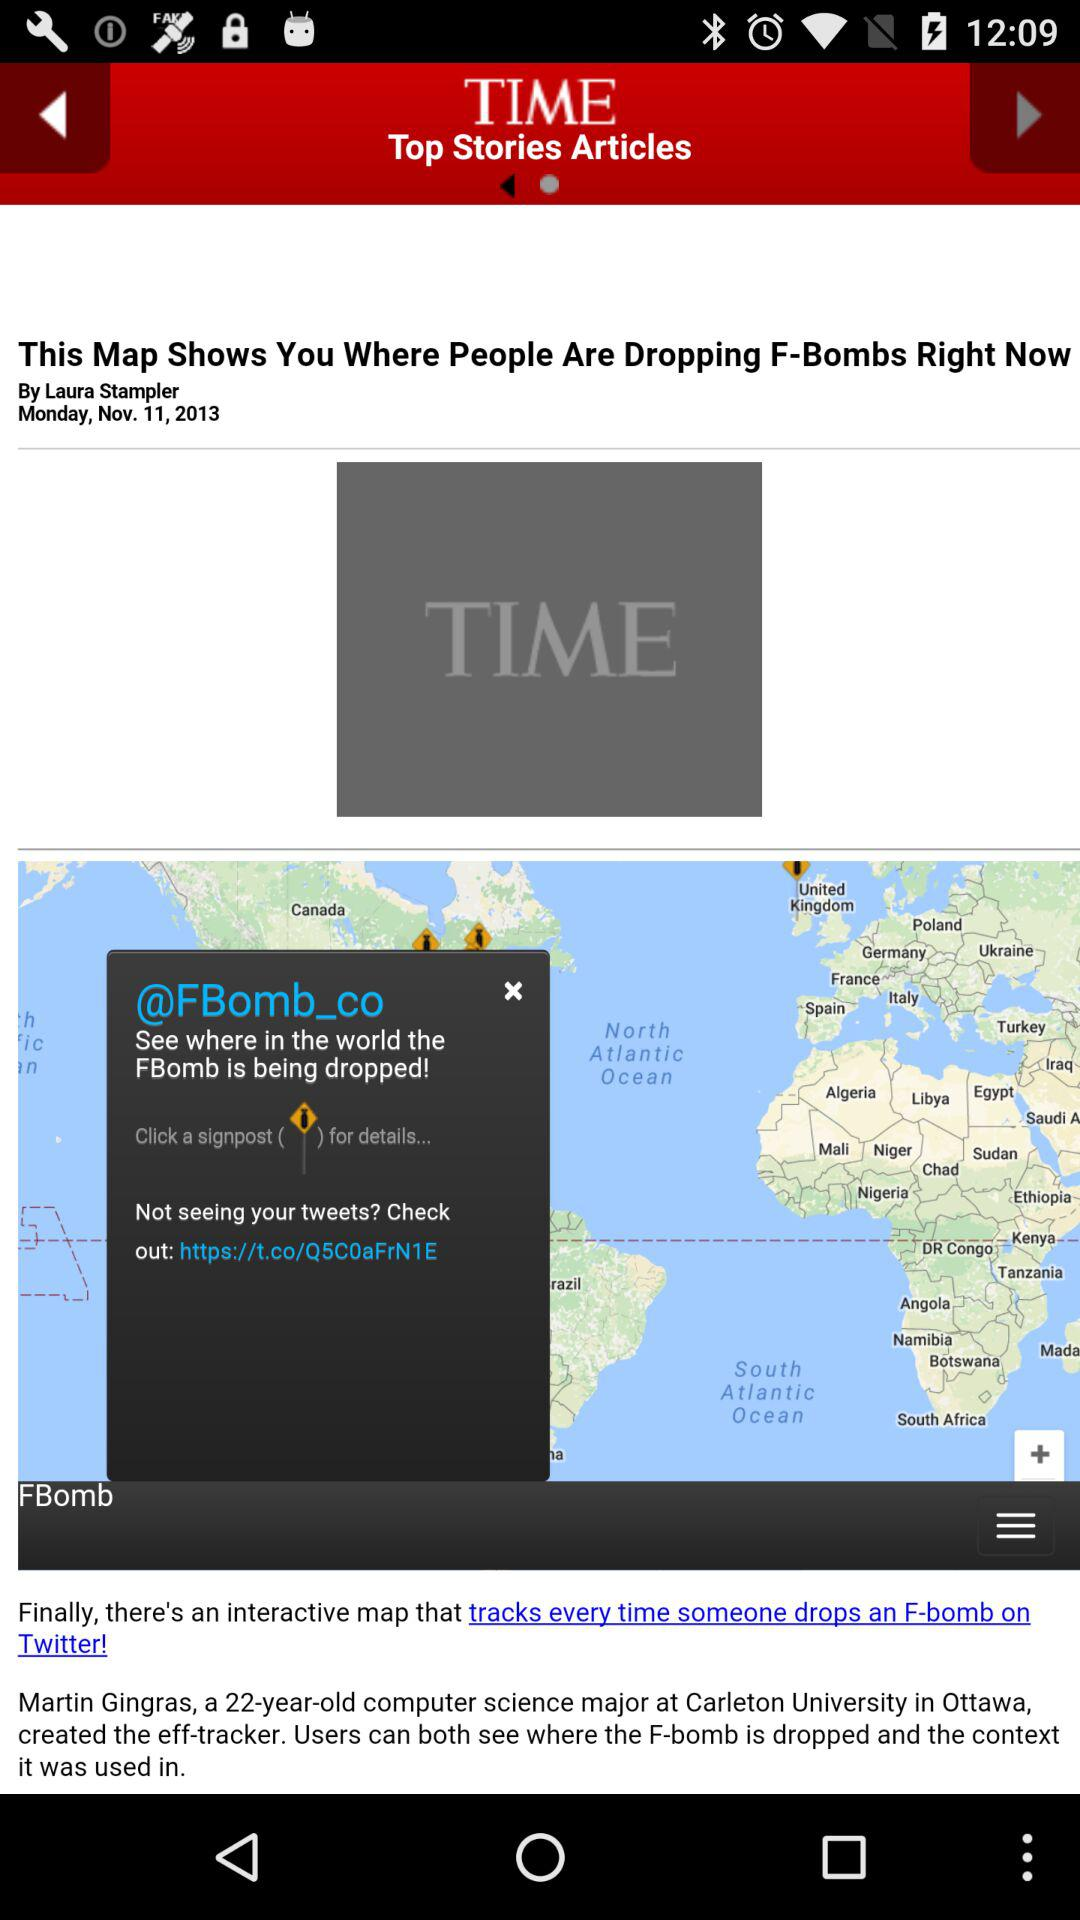Where are all the "FBomb"s dropped?
When the provided information is insufficient, respond with <no answer>. <no answer> 